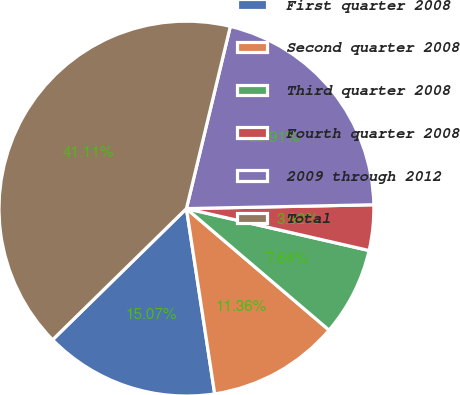Convert chart. <chart><loc_0><loc_0><loc_500><loc_500><pie_chart><fcel>First quarter 2008<fcel>Second quarter 2008<fcel>Third quarter 2008<fcel>Fourth quarter 2008<fcel>2009 through 2012<fcel>Total<nl><fcel>15.07%<fcel>11.36%<fcel>7.64%<fcel>3.92%<fcel>20.91%<fcel>41.11%<nl></chart> 